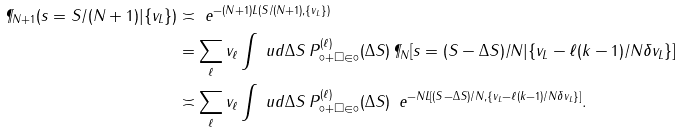<formula> <loc_0><loc_0><loc_500><loc_500>\P _ { N + 1 } ( s = S / ( N + 1 ) | \{ v _ { L } \} ) & \asymp \ e ^ { - ( N + 1 ) L ( S / ( N + 1 ) , \{ v _ { L } \} ) } \\ & = \sum _ { \ell } v _ { \ell } \int \ u d \Delta S \, P _ { \circ + \square \in \circ } ^ { ( \ell ) } ( \Delta S ) \, \P _ { N } [ s = ( S - \Delta S ) / N | \{ v _ { L } - \ell ( k - 1 ) / N \delta v _ { L } \} ] \\ & \asymp \sum _ { \ell } v _ { \ell } \int \ u d \Delta S \, P _ { \circ + \square \in \circ } ^ { ( \ell ) } ( \Delta S ) \, \ e ^ { - N L [ ( S - \Delta S ) / N , \{ v _ { L } - \ell ( k - 1 ) / N \delta v _ { L } \} ] } .</formula> 